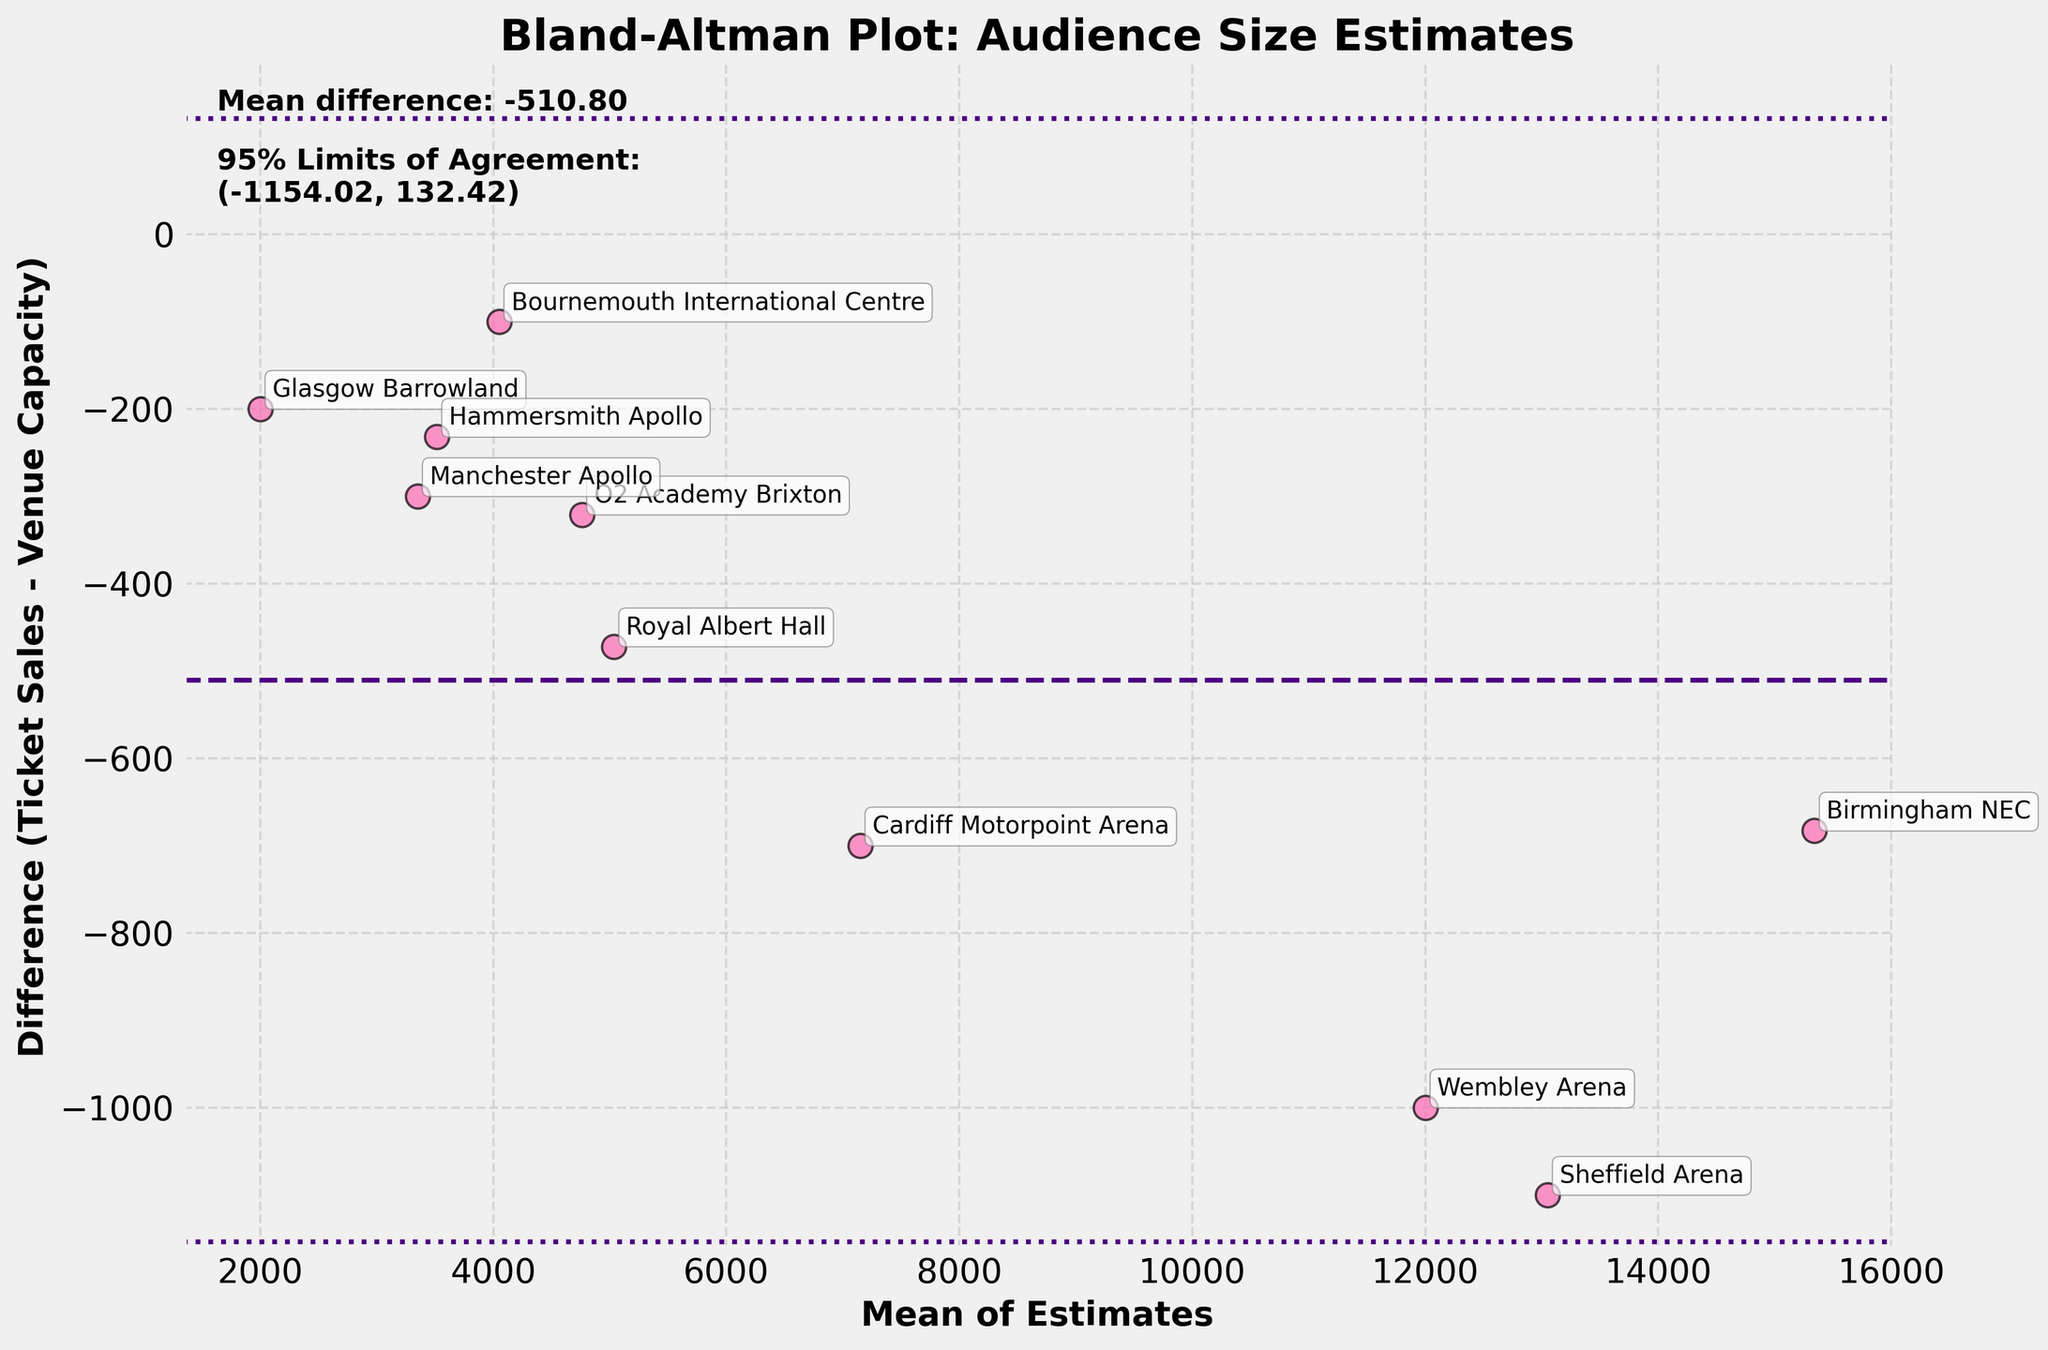What is the title of the figure? The title of the figure is usually displayed at the top and provides a summary of what the figure is about. Here, it is clearly marked.
Answer: Bland-Altman Plot: Audience Size Estimates How many data points are there in the plot? By counting the number of individual points marked on the scatter plot, you can determine the total number of data points
Answer: 10 What is the mean difference displayed in the figure? The mean difference is typically indicated by a horizontal line and often annotated with text for clarity. Here, it is shown on the plot
Answer: -511 Which venue has the largest negative difference between ticket sales and venue capacity? By scanning the differences plotted on the y-axis, the point with the largest negative difference is identified. The venue associated with this point can be found via the annotation.
Answer: Sheffield Arena What are the 95% limits of agreement on the plot? These limits are typically marked by dashed lines above and below the mean difference. The exact values are often annotated for clarity.
Answer: (-1135.18, 113.18) Which data point has the smallest difference between ticket sales and venue capacity? By identifying the point that is closest to zero on the y-axis, you can determine the smallest difference. The associated venue can be found via the annotation.
Answer: Bournemouth International Centre What is the standard deviation for the differences shown in the plot? The standard deviation is illustrated by the spread of the limits of agreement lines around the mean difference. It can be calculated as (upper limit - lower limit) / (2 * 1.96).
Answer: 317.50 How many data points are above the mean difference? Count the number of points that are plotted above the horizontal line representing the mean difference
Answer: 0 What does the x-axis represent? The label of the x-axis will provide an explanation. Here it is indicated clearly.
Answer: Mean of Estimates Is there any venue where the ticket sales are greater than the venue capacity? By examining the plotted differences, a point with a positive value can be identified, indicating the condition.
Answer: No 